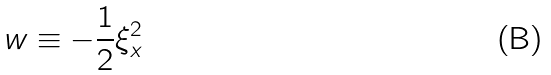<formula> <loc_0><loc_0><loc_500><loc_500>w \equiv - \frac { 1 } { 2 } \xi _ { x } ^ { 2 }</formula> 